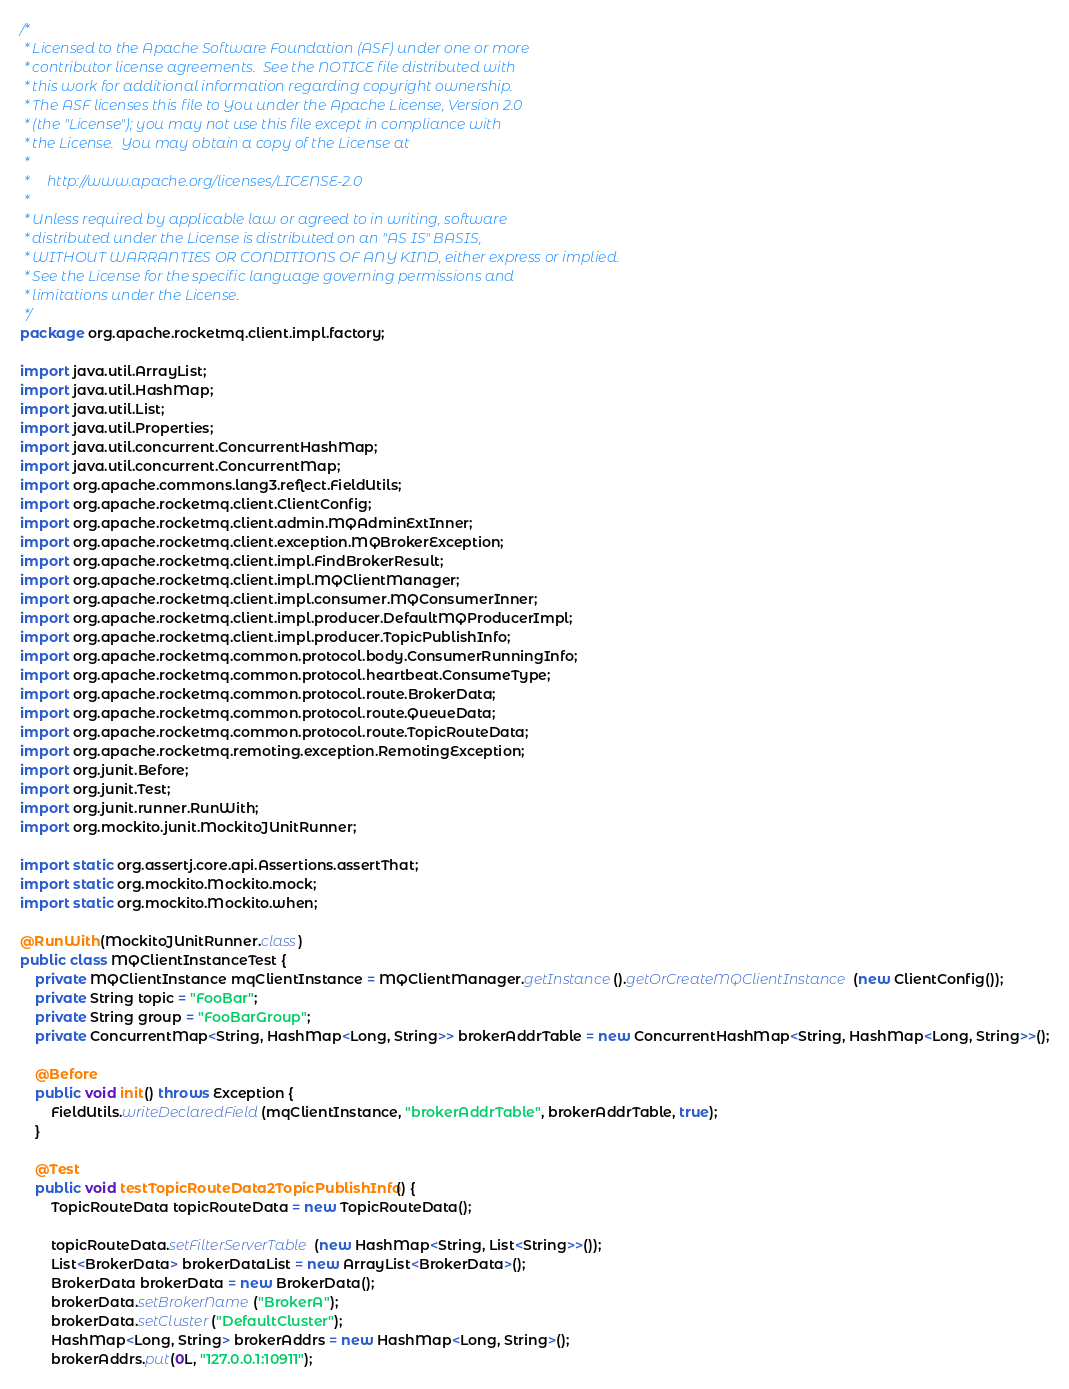Convert code to text. <code><loc_0><loc_0><loc_500><loc_500><_Java_>/*
 * Licensed to the Apache Software Foundation (ASF) under one or more
 * contributor license agreements.  See the NOTICE file distributed with
 * this work for additional information regarding copyright ownership.
 * The ASF licenses this file to You under the Apache License, Version 2.0
 * (the "License"); you may not use this file except in compliance with
 * the License.  You may obtain a copy of the License at
 *
 *     http://www.apache.org/licenses/LICENSE-2.0
 *
 * Unless required by applicable law or agreed to in writing, software
 * distributed under the License is distributed on an "AS IS" BASIS,
 * WITHOUT WARRANTIES OR CONDITIONS OF ANY KIND, either express or implied.
 * See the License for the specific language governing permissions and
 * limitations under the License.
 */
package org.apache.rocketmq.client.impl.factory;

import java.util.ArrayList;
import java.util.HashMap;
import java.util.List;
import java.util.Properties;
import java.util.concurrent.ConcurrentHashMap;
import java.util.concurrent.ConcurrentMap;
import org.apache.commons.lang3.reflect.FieldUtils;
import org.apache.rocketmq.client.ClientConfig;
import org.apache.rocketmq.client.admin.MQAdminExtInner;
import org.apache.rocketmq.client.exception.MQBrokerException;
import org.apache.rocketmq.client.impl.FindBrokerResult;
import org.apache.rocketmq.client.impl.MQClientManager;
import org.apache.rocketmq.client.impl.consumer.MQConsumerInner;
import org.apache.rocketmq.client.impl.producer.DefaultMQProducerImpl;
import org.apache.rocketmq.client.impl.producer.TopicPublishInfo;
import org.apache.rocketmq.common.protocol.body.ConsumerRunningInfo;
import org.apache.rocketmq.common.protocol.heartbeat.ConsumeType;
import org.apache.rocketmq.common.protocol.route.BrokerData;
import org.apache.rocketmq.common.protocol.route.QueueData;
import org.apache.rocketmq.common.protocol.route.TopicRouteData;
import org.apache.rocketmq.remoting.exception.RemotingException;
import org.junit.Before;
import org.junit.Test;
import org.junit.runner.RunWith;
import org.mockito.junit.MockitoJUnitRunner;

import static org.assertj.core.api.Assertions.assertThat;
import static org.mockito.Mockito.mock;
import static org.mockito.Mockito.when;

@RunWith(MockitoJUnitRunner.class)
public class MQClientInstanceTest {
    private MQClientInstance mqClientInstance = MQClientManager.getInstance().getOrCreateMQClientInstance(new ClientConfig());
    private String topic = "FooBar";
    private String group = "FooBarGroup";
    private ConcurrentMap<String, HashMap<Long, String>> brokerAddrTable = new ConcurrentHashMap<String, HashMap<Long, String>>();

    @Before
    public void init() throws Exception {
        FieldUtils.writeDeclaredField(mqClientInstance, "brokerAddrTable", brokerAddrTable, true);
    }

    @Test
    public void testTopicRouteData2TopicPublishInfo() {
        TopicRouteData topicRouteData = new TopicRouteData();

        topicRouteData.setFilterServerTable(new HashMap<String, List<String>>());
        List<BrokerData> brokerDataList = new ArrayList<BrokerData>();
        BrokerData brokerData = new BrokerData();
        brokerData.setBrokerName("BrokerA");
        brokerData.setCluster("DefaultCluster");
        HashMap<Long, String> brokerAddrs = new HashMap<Long, String>();
        brokerAddrs.put(0L, "127.0.0.1:10911");</code> 